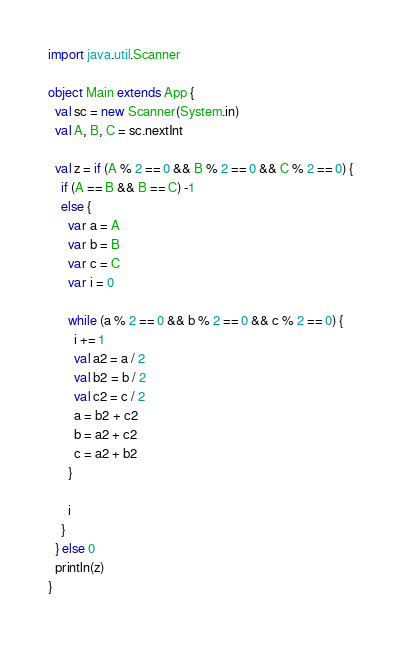<code> <loc_0><loc_0><loc_500><loc_500><_Scala_>import java.util.Scanner

object Main extends App {
  val sc = new Scanner(System.in)
  val A, B, C = sc.nextInt

  val z = if (A % 2 == 0 && B % 2 == 0 && C % 2 == 0) {
    if (A == B && B == C) -1
    else {
      var a = A
      var b = B
      var c = C
      var i = 0

      while (a % 2 == 0 && b % 2 == 0 && c % 2 == 0) {
        i += 1
        val a2 = a / 2
        val b2 = b / 2
        val c2 = c / 2
        a = b2 + c2
        b = a2 + c2
        c = a2 + b2
      }

      i
    }
  } else 0
  println(z)
}
</code> 